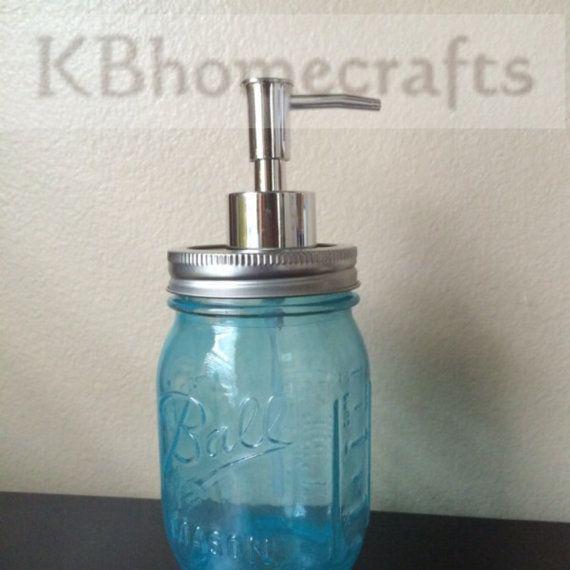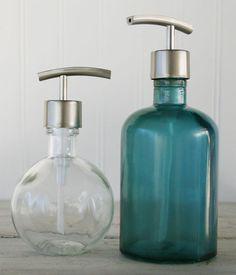The first image is the image on the left, the second image is the image on the right. For the images displayed, is the sentence "There are two bottles total from both images." factually correct? Answer yes or no. No. The first image is the image on the left, the second image is the image on the right. Given the left and right images, does the statement "In one image a canning jar has been accessorized with a metal pump top." hold true? Answer yes or no. Yes. 